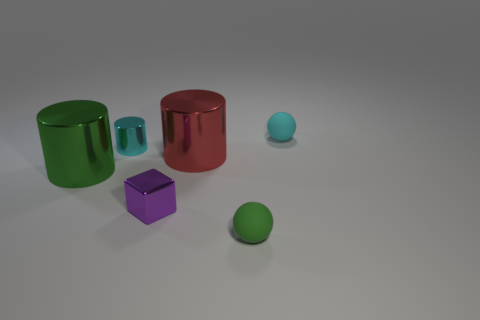Are there any tiny yellow objects made of the same material as the purple thing?
Provide a short and direct response. No. What material is the purple cube that is the same size as the green ball?
Your answer should be very brief. Metal. How big is the object that is to the right of the rubber thing that is in front of the big object right of the tiny cyan shiny cylinder?
Keep it short and to the point. Small. There is a cylinder that is behind the big red object; are there any small blocks behind it?
Give a very brief answer. No. There is a big red object; is its shape the same as the small shiny object that is to the right of the cyan metallic cylinder?
Ensure brevity in your answer.  No. There is a big shiny cylinder to the right of the purple metal cube; what color is it?
Offer a very short reply. Red. How big is the matte sphere on the left side of the sphere that is behind the red cylinder?
Provide a short and direct response. Small. Do the large thing that is on the left side of the small shiny block and the small purple object have the same shape?
Ensure brevity in your answer.  No. What material is the tiny cyan object that is the same shape as the big green metal thing?
Your response must be concise. Metal. What number of things are either small objects that are right of the tiny cyan cylinder or small green balls on the right side of the cyan metallic cylinder?
Give a very brief answer. 3. 